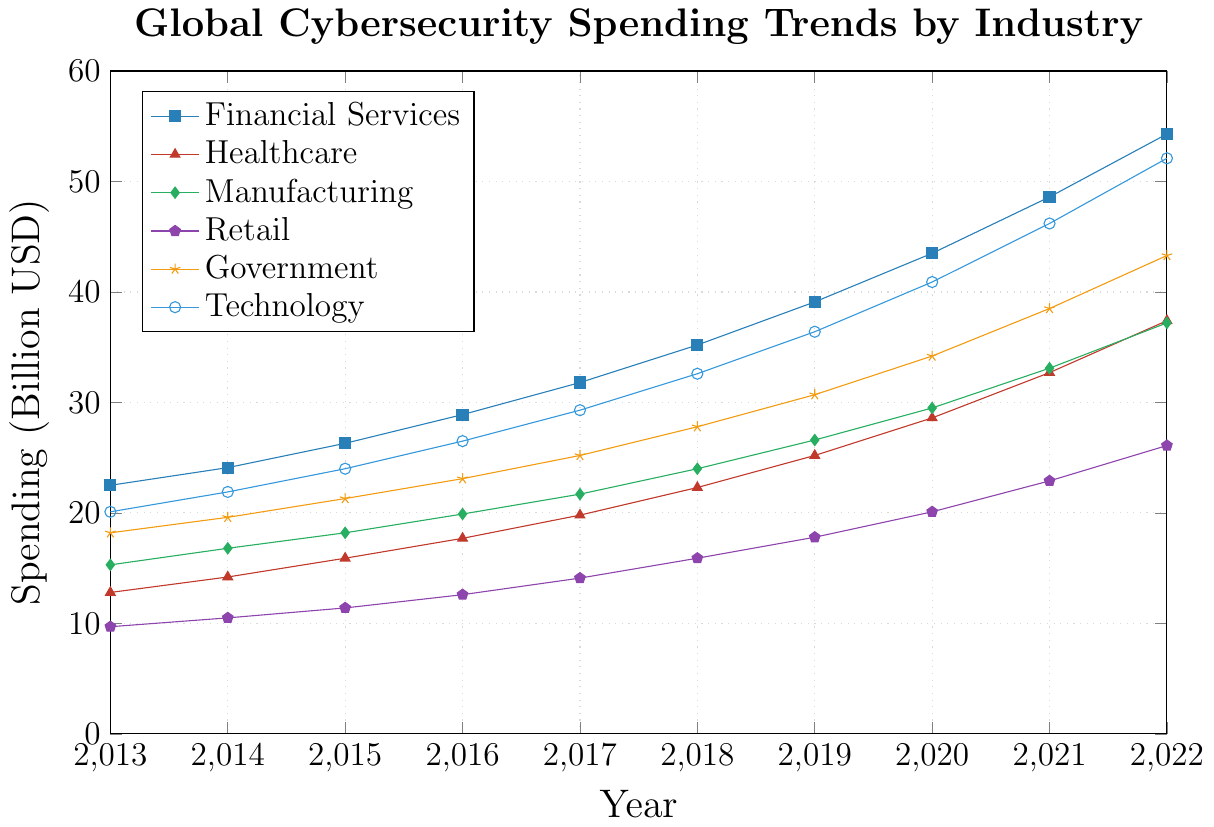Which industry had the highest cybersecurity spending in 2022? The line representing each industry's spending is plotted on the graph. The highest point on these lines for 2022 indicates the maximum spending.
The Technology sector is at the topmost point, near $52.1 billion.
Answer: Technology Which industry saw the smallest increase in absolute spending from 2013 to 2022? Calculate the difference between 2022 and 2013 spending for each industry: Financial Services (54.3-22.5), Healthcare (37.4-12.8), Manufacturing (37.2-15.3), Retail (26.1-9.7), Government (43.3-18.2), Technology (52.1-20.1). Find the smallest value.
Retail's increase is 26.1-9.7 = 16.4 billion, which is the smallest.
Answer: Retail What is the total cybersecurity spending across all industries in 2022? Add the values for each industry in 2022: Financial Services (54.3), Healthcare (37.4), Manufacturing (37.2), Retail (26.1), Government (43.3), Technology (52.1). 
54.3 + 37.4 + 37.2 + 26.1 + 43.3 + 52.1 = 250.4 billion USD.
Answer: 250.4 billion USD Identify the industry that had the highest increase in spending from 2020 to 2021. Calculate the difference between 2021 and 2020 for each industry: Financial Services (48.6-43.5), Healthcare (32.7-28.6), Manufacturing (33.1-29.5), Retail (22.9-20.1), Government (38.5-34.2), Technology (46.2-40.9). Find the highest value.
Financial Services had the highest increase: 48.6-43.5 = 5.1 billion.
Answer: Financial Services Between 2015 and 2019, which industry had the least consistent (most variable) spending? Assess the variability of spending values in the period 2015 to 2019 for each industry by visually comparing the line's fluctuations on the graph. 
Healthcare shows the most variability, with significant fluctuations between the years.
Answer: Healthcare How does the spending trend in the Financial Services industry compare to the Technology industry from 2013 to 2022? Examine the trend lines for Financial Services and Technology from 2013 to 2022. Compare the trajectories and growth.
Both have upward trends, but Financial Services consistently spends higher and shows a relatively steadier increase, while Technology shows a slightly more rapid increase in the latter years.
Answer: Upward, Financial Services higher Which two industries had the closest spending values in 2017? Compare the values of all industries in 2017 and find the two with the smallest difference: Financial Services (31.8), Healthcare (19.8), Manufacturing (21.7), Retail (14.1), Government (25.2), Technology (29.3).
Manufacturing (21.7) and Healthcare (19.8) are closest in spending.
Answer: Manufacturing and Healthcare What is the average annual spending growth for the Healthcare industry from 2013 to 2022? Calculate the annual spending growth for each year, then find the average: (14.2-12.8), (15.9-14.2), (17.7-15.9), (19.8-17.7), (22.3-19.8), (25.2-22.3), (28.6-25.2), (32.7-28.6), (37.4-32.7). 
Total growth: (1.4, 1.7, 1.8, 2.1, 2.5, 2.9, 3.4, 4.1, 4.7). 
Average: (1.4+1.7+1.8+2.1+2.5+2.9+3.4+4.1+4.7) / 9 = 2.94 billion/year.
Answer: 2.94 billion USD/year Compare the rate of increase in spending for Manufacturing and Government from 2015 to 2020. Calculate the overall increase from 2015 to 2020 for both Manufacturing (29.5-18.2) and Government (34.2-21.3). Compare the rate of increase.
Manufacturing increase: 29.5-18.2 = 11.3 billion.
Government increase: 34.2-21.3 = 12.9 billion. Government's spending increased more.
Answer: Government Which year did Retail experience the most significant increase in cybersecurity spending, and by how much? Calculate the annual increase for Retail: (10.5-9.7), (11.4-10.5), (12.6-11.4), (14.1-12.6), (15.9-14.1), (17.8-15.9), (20.1-17.8), (22.9-20.1), (26.1-22.9). Identify the highest increase.
Most significant increase is from 2021 to 2022: 26.1-22.9 = 3.2 billion.
Answer: 2021 to 2022, 3.2 billion 